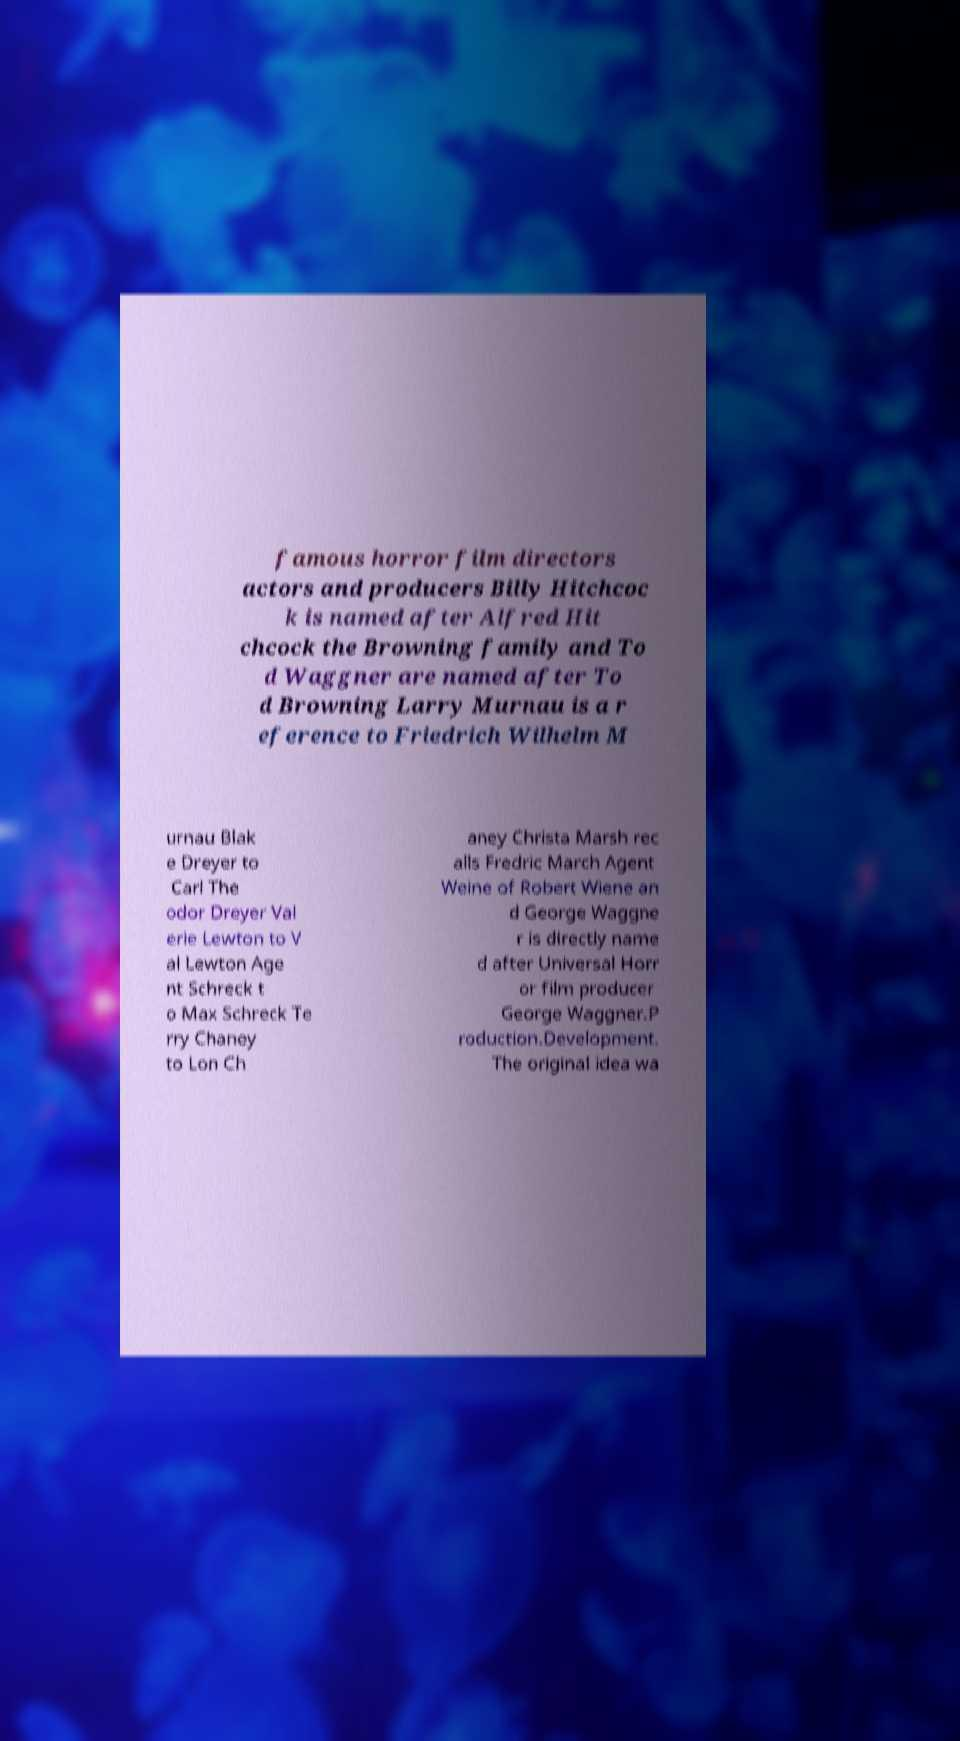There's text embedded in this image that I need extracted. Can you transcribe it verbatim? famous horror film directors actors and producers Billy Hitchcoc k is named after Alfred Hit chcock the Browning family and To d Waggner are named after To d Browning Larry Murnau is a r eference to Friedrich Wilhelm M urnau Blak e Dreyer to Carl The odor Dreyer Val erie Lewton to V al Lewton Age nt Schreck t o Max Schreck Te rry Chaney to Lon Ch aney Christa Marsh rec alls Fredric March Agent Weine of Robert Wiene an d George Waggne r is directly name d after Universal Horr or film producer George Waggner.P roduction.Development. The original idea wa 